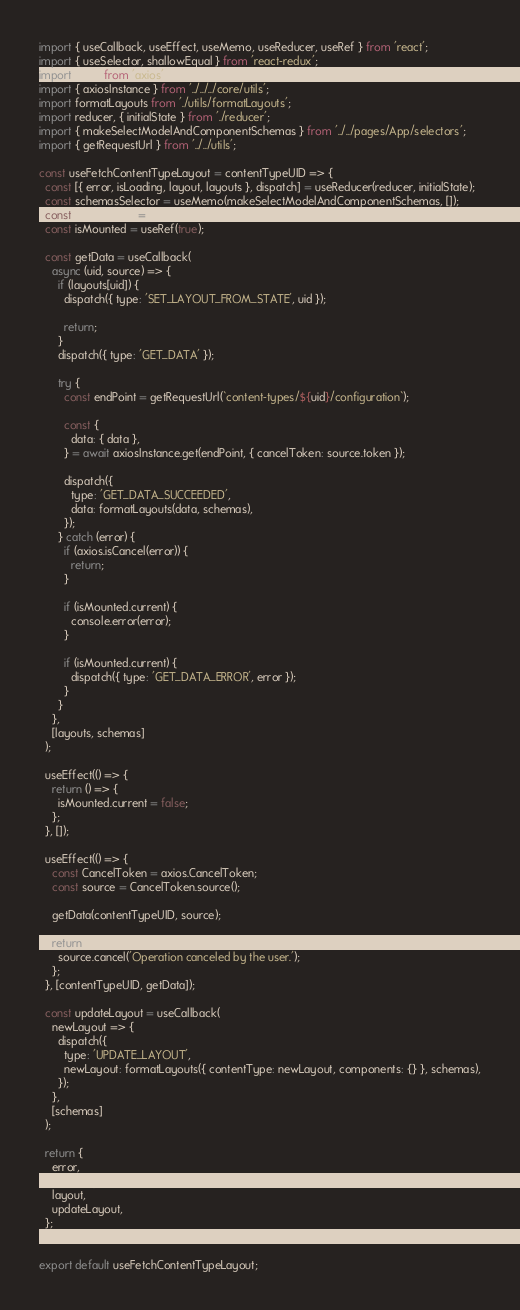Convert code to text. <code><loc_0><loc_0><loc_500><loc_500><_JavaScript_>import { useCallback, useEffect, useMemo, useReducer, useRef } from 'react';
import { useSelector, shallowEqual } from 'react-redux';
import axios from 'axios';
import { axiosInstance } from '../../../core/utils';
import formatLayouts from './utils/formatLayouts';
import reducer, { initialState } from './reducer';
import { makeSelectModelAndComponentSchemas } from '../../pages/App/selectors';
import { getRequestUrl } from '../../utils';

const useFetchContentTypeLayout = contentTypeUID => {
  const [{ error, isLoading, layout, layouts }, dispatch] = useReducer(reducer, initialState);
  const schemasSelector = useMemo(makeSelectModelAndComponentSchemas, []);
  const { schemas } = useSelector(state => schemasSelector(state), shallowEqual);
  const isMounted = useRef(true);

  const getData = useCallback(
    async (uid, source) => {
      if (layouts[uid]) {
        dispatch({ type: 'SET_LAYOUT_FROM_STATE', uid });

        return;
      }
      dispatch({ type: 'GET_DATA' });

      try {
        const endPoint = getRequestUrl(`content-types/${uid}/configuration`);

        const {
          data: { data },
        } = await axiosInstance.get(endPoint, { cancelToken: source.token });

        dispatch({
          type: 'GET_DATA_SUCCEEDED',
          data: formatLayouts(data, schemas),
        });
      } catch (error) {
        if (axios.isCancel(error)) {
          return;
        }

        if (isMounted.current) {
          console.error(error);
        }

        if (isMounted.current) {
          dispatch({ type: 'GET_DATA_ERROR', error });
        }
      }
    },
    [layouts, schemas]
  );

  useEffect(() => {
    return () => {
      isMounted.current = false;
    };
  }, []);

  useEffect(() => {
    const CancelToken = axios.CancelToken;
    const source = CancelToken.source();

    getData(contentTypeUID, source);

    return () => {
      source.cancel('Operation canceled by the user.');
    };
  }, [contentTypeUID, getData]);

  const updateLayout = useCallback(
    newLayout => {
      dispatch({
        type: 'UPDATE_LAYOUT',
        newLayout: formatLayouts({ contentType: newLayout, components: {} }, schemas),
      });
    },
    [schemas]
  );

  return {
    error,
    isLoading,
    layout,
    updateLayout,
  };
};

export default useFetchContentTypeLayout;
</code> 